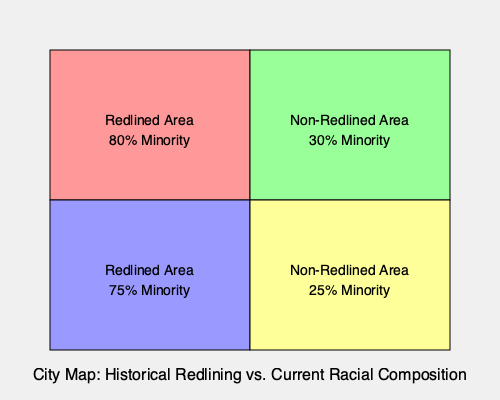Analyze the map showing historical redlining practices and current racial composition in a city. Calculate the correlation coefficient between redlining status (redlined = 1, non-redlined = 0) and minority population percentage. What does this coefficient suggest about the long-term effects of redlining on racial segregation? To analyze the correlation between redlining practices and current racial composition, we'll follow these steps:

1. Identify the variables:
   X (Redlining status): Redlined = 1, Non-redlined = 0
   Y (Minority population percentage)

2. Create a dataset from the map:
   Area 1: X = 1, Y = 80%
   Area 2: X = 0, Y = 30%
   Area 3: X = 1, Y = 75%
   Area 4: X = 0, Y = 25%

3. Calculate the means:
   $\bar{X} = \frac{1 + 0 + 1 + 0}{4} = 0.5$
   $\bar{Y} = \frac{80 + 30 + 75 + 25}{4} = 52.5$

4. Calculate the variances:
   $s_X^2 = \frac{(1-0.5)^2 + (0-0.5)^2 + (1-0.5)^2 + (0-0.5)^2}{3} = 0.3333$
   $s_Y^2 = \frac{(80-52.5)^2 + (30-52.5)^2 + (75-52.5)^2 + (25-52.5)^2}{3} = 729.1667$

5. Calculate the covariance:
   $s_{XY} = \frac{(1-0.5)(80-52.5) + (0-0.5)(30-52.5) + (1-0.5)(75-52.5) + (0-0.5)(25-52.5)}{3} = 25$

6. Calculate the correlation coefficient:
   $r = \frac{s_{XY}}{\sqrt{s_X^2 \cdot s_Y^2}} = \frac{25}{\sqrt{0.3333 \cdot 729.1667}} = 0.9805$

7. Interpret the result:
   The correlation coefficient of 0.9805 indicates a very strong positive correlation between historical redlining practices and current minority population percentages. This suggests that areas that were historically redlined tend to have significantly higher minority populations today, while non-redlined areas have lower minority populations. This strong correlation implies that the effects of redlining have persisted over time, contributing to ongoing racial segregation in the city.
Answer: Correlation coefficient: 0.9805. This indicates a strong positive correlation between historical redlining and current racial composition, suggesting persistent effects of redlining on racial segregation. 